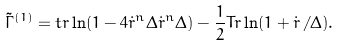Convert formula to latex. <formula><loc_0><loc_0><loc_500><loc_500>\tilde { \Gamma } ^ { ( 1 ) } = t r \ln ( 1 - 4 \dot { r } ^ { n } \Delta \dot { r } ^ { n } \Delta ) - \frac { 1 } { 2 } T r \ln ( { 1 } + \dot { r } \, / \Delta ) .</formula> 